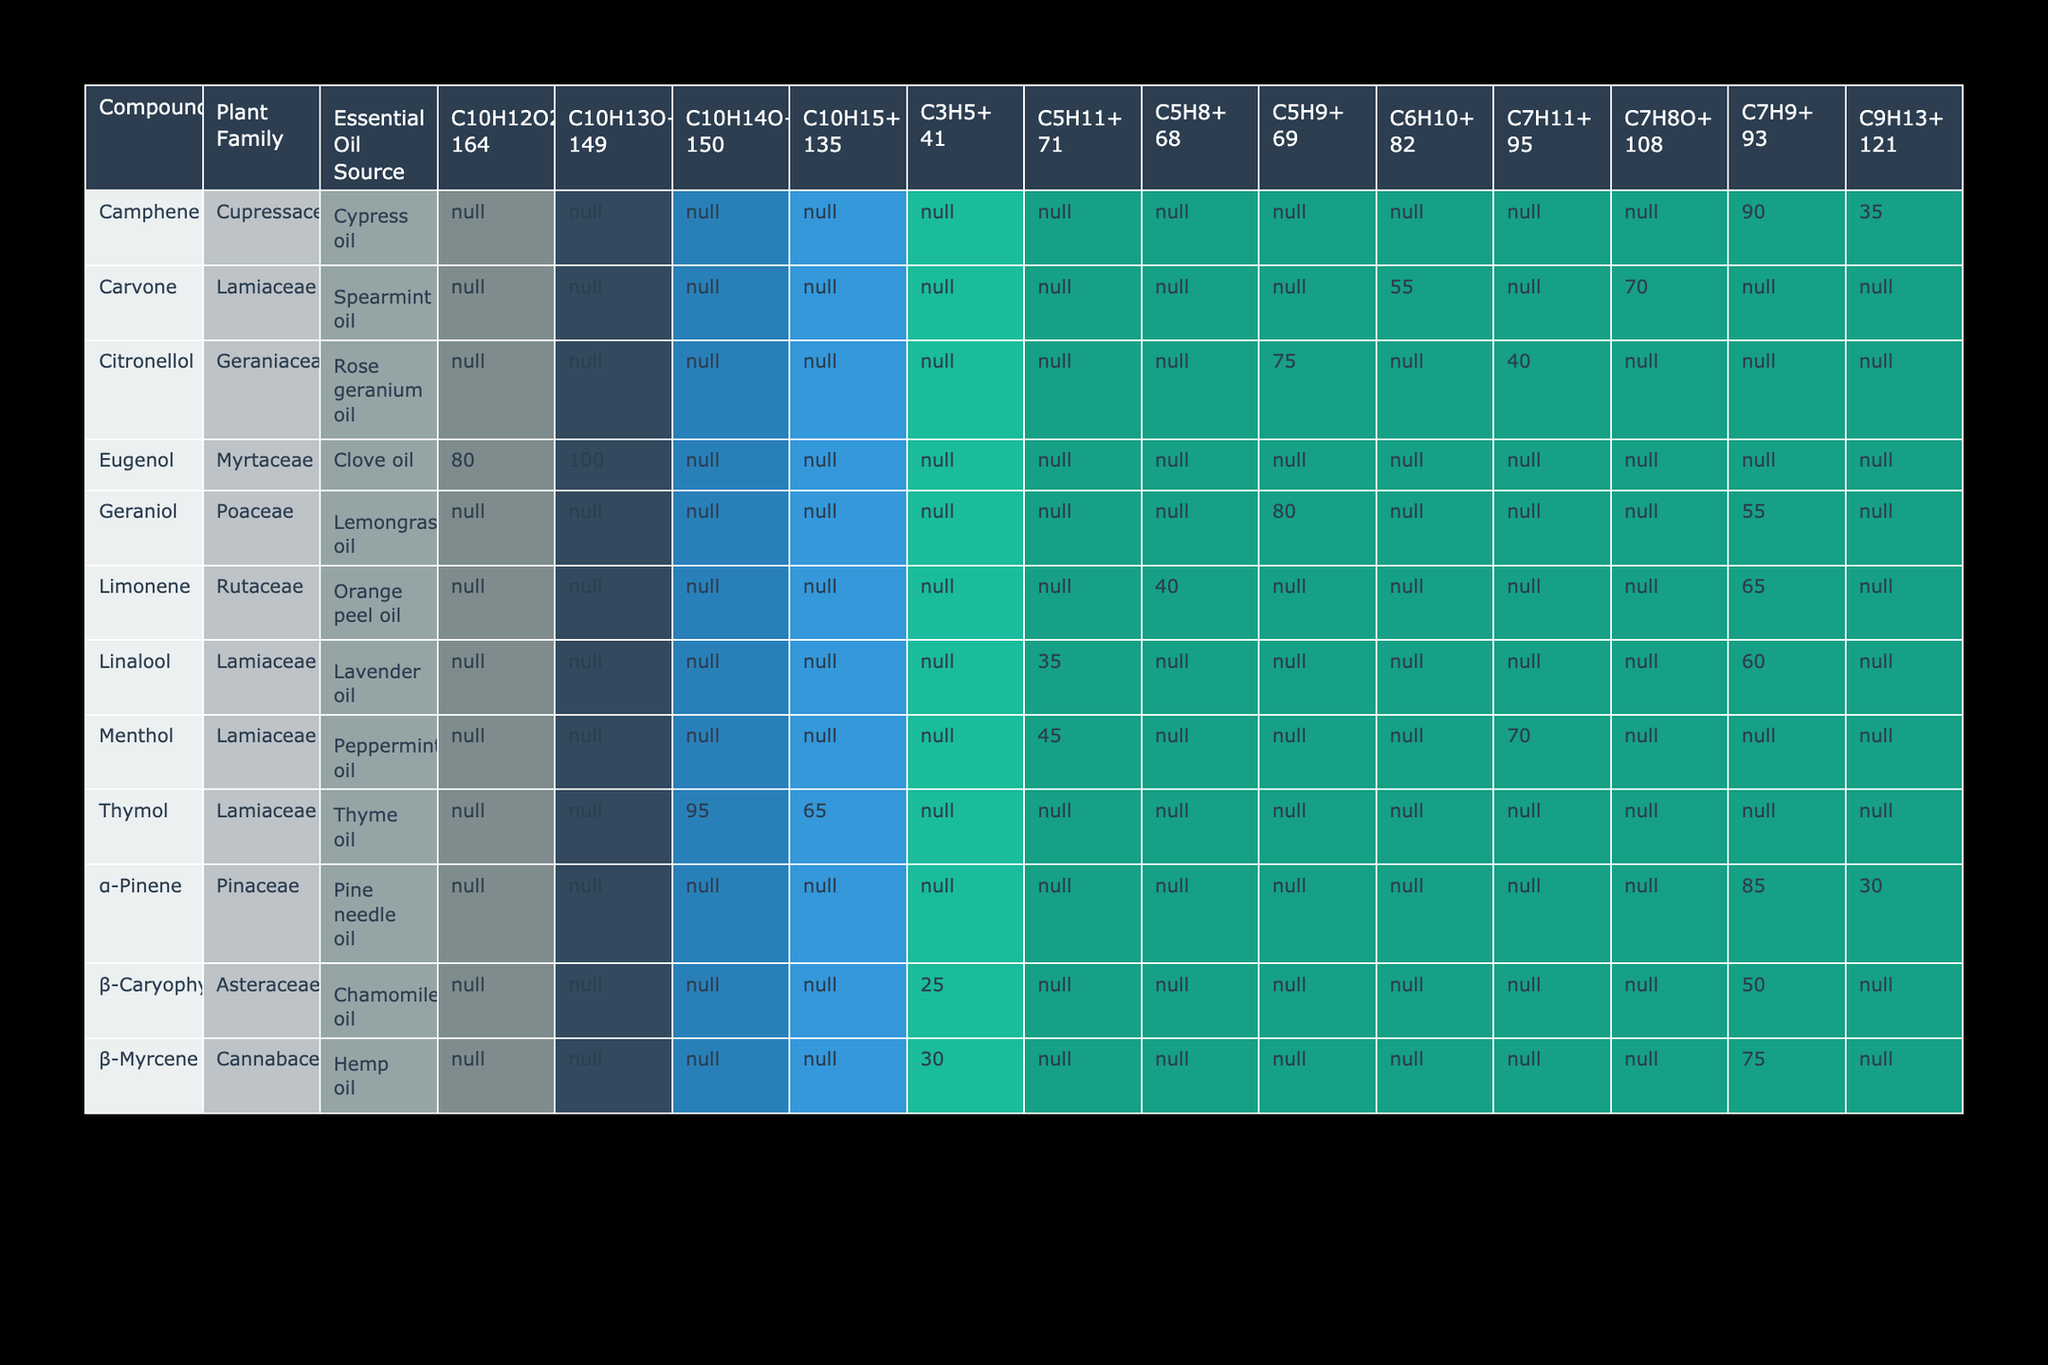What is the highest relative intensity observed for any fragment type? By inspecting the table, I look for the highest relative intensity value listed. I can see the relative intensities are 85, 30, 40, 65, 25, 50, 35, 60, 100, 80, 45, 70, 80, 55, 75, 90, 35, 55, 70, 65, 95, 30, and 75. The maximum value among these is 100, associated with Eugenol's C10H13O+ fragment at m/z value 149.
Answer: 100 How many different plant families are represented in the table? I can count the unique plant families listed in the table under the "Plant Family" column. They are: Pinaceae, Rutaceae, Asteraceae, Lamiaceae, Myrtaceae, Poaceae, Geraniaceae, and Cupressaceae, which totals to 8 different plant families.
Answer: 8 Which compound has the lowest relative intensity and what is its value? To find the lowest relative intensity, I examine all the values, noticing that the minimum relative intensity listed is 25, which pertains to β-Caryophyllene's C3H5+ fragment at m/z value 41.
Answer: 25 Is it true that all compounds from the Lamiaceae family have a fragment type with relative intensity above 50? I need to check each compound from the Lamiaceae family and see their respective relative intensities. I find that Linalool has a relative intensity of 35 for the C5H11+ fragment, confirming that not all Lamiaceae compounds exceed 50. Thus, the statement is false.
Answer: No What is the average relative intensity for compounds from the Myrtaceae family? To obtain the average relative intensity for Myrtaceae, I first identify their values: Eugenol has 100 and 80 as relative intensities. I then calculate their average: (100 + 80) / 2 = 90. Hence, the average relative intensity for Myrtaceae is 90.
Answer: 90 Which m/z value is most frequently associated with the compounds listed in the table? I count the occurrences of each m/z value within the table: 93 appears most frequently, associated with fragments for five different compounds (α-Pinene, Limonene, β-Caryophyllene, Linalool, Citronellol, Camphene, and β-Myrcene), confirming this is the most common value.
Answer: 93 How many total fragment types are associated with the compound Geraniol? I can look at the entries for Geraniol and see it has two fragments: C5H9+ at m/z 69 and C7H9+ at m/z 93, indicating there are two distinct fragment types for this compound.
Answer: 2 What is the total relative intensity of all fragment types for the compound Menthol? I find the two entries for Menthol: 45 for C5H11+ at m/z 71 and 70 for C7H11+ at m/z 95. The total relative intensity sums up to 45 + 70, which equals 115.
Answer: 115 